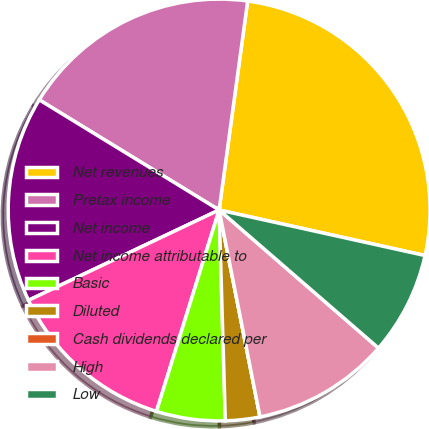Convert chart to OTSL. <chart><loc_0><loc_0><loc_500><loc_500><pie_chart><fcel>Net revenues<fcel>Pretax income<fcel>Net income<fcel>Net income attributable to<fcel>Basic<fcel>Diluted<fcel>Cash dividends declared per<fcel>High<fcel>Low<nl><fcel>26.31%<fcel>18.42%<fcel>15.79%<fcel>13.16%<fcel>5.27%<fcel>2.64%<fcel>0.0%<fcel>10.53%<fcel>7.9%<nl></chart> 